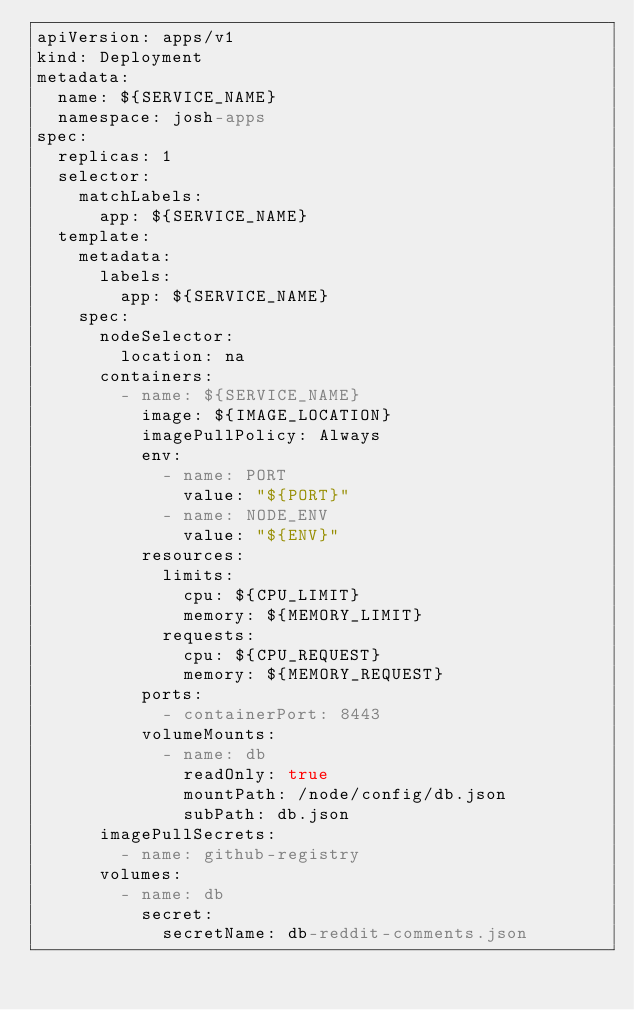Convert code to text. <code><loc_0><loc_0><loc_500><loc_500><_YAML_>apiVersion: apps/v1
kind: Deployment
metadata:
  name: ${SERVICE_NAME}
  namespace: josh-apps
spec:
  replicas: 1
  selector:
    matchLabels:
      app: ${SERVICE_NAME}
  template:
    metadata:
      labels:
        app: ${SERVICE_NAME}
    spec:
      nodeSelector:
        location: na
      containers:
        - name: ${SERVICE_NAME}
          image: ${IMAGE_LOCATION}
          imagePullPolicy: Always
          env:
            - name: PORT
              value: "${PORT}"
            - name: NODE_ENV
              value: "${ENV}"
          resources:
            limits:
              cpu: ${CPU_LIMIT}
              memory: ${MEMORY_LIMIT}
            requests:
              cpu: ${CPU_REQUEST}
              memory: ${MEMORY_REQUEST}
          ports:
            - containerPort: 8443
          volumeMounts:
            - name: db
              readOnly: true
              mountPath: /node/config/db.json
              subPath: db.json
      imagePullSecrets:
        - name: github-registry
      volumes:
        - name: db
          secret:
            secretName: db-reddit-comments.json
</code> 